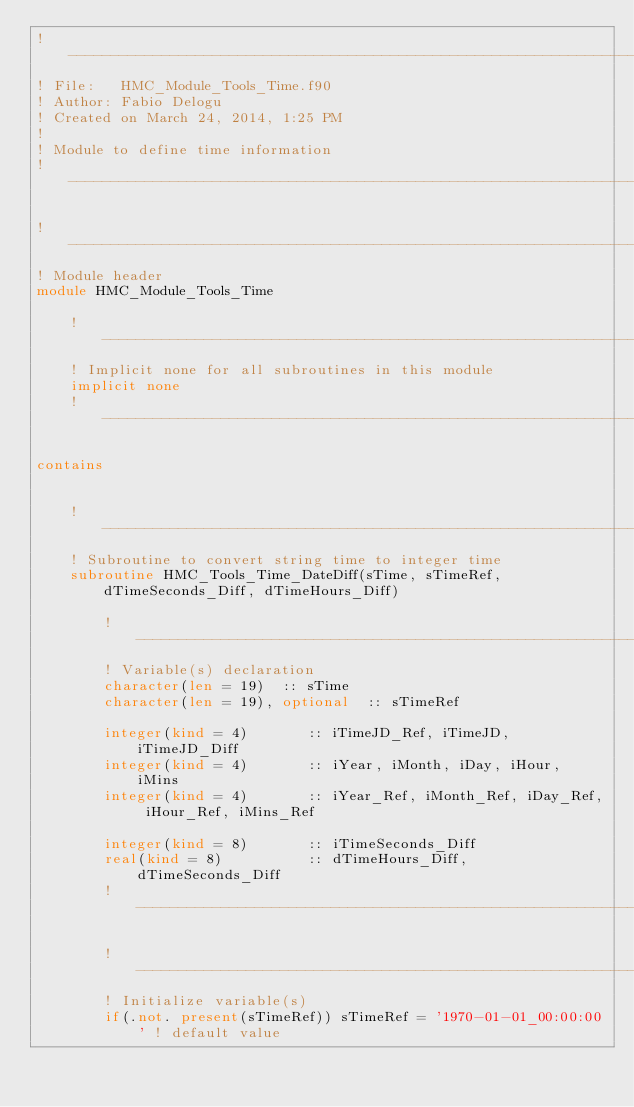Convert code to text. <code><loc_0><loc_0><loc_500><loc_500><_FORTRAN_>!------------------------------------------------------------------------------------------     
! File:   HMC_Module_Tools_Time.f90
! Author: Fabio Delogu
! Created on March 24, 2014, 1:25 PM
!
! Module to define time information
!------------------------------------------------------------------------------------------

!------------------------------------------------------------------------------------------
! Module header
module HMC_Module_Tools_Time
    
    !------------------------------------------------------------------------------------------
    ! Implicit none for all subroutines in this module
    implicit none
    !------------------------------------------------------------------------------------------
    
contains   
    
    
    !------------------------------------------------------------------------------------------
    ! Subroutine to convert string time to integer time
    subroutine HMC_Tools_Time_DateDiff(sTime, sTimeRef, dTimeSeconds_Diff, dTimeHours_Diff)
        
        !------------------------------------------------------------------------------------------
        ! Variable(s) declaration
        character(len = 19)  :: sTime
        character(len = 19), optional  :: sTimeRef
        
        integer(kind = 4)       :: iTimeJD_Ref, iTimeJD, iTimeJD_Diff
        integer(kind = 4)       :: iYear, iMonth, iDay, iHour, iMins
        integer(kind = 4)       :: iYear_Ref, iMonth_Ref, iDay_Ref, iHour_Ref, iMins_Ref
        
        integer(kind = 8)       :: iTimeSeconds_Diff
        real(kind = 8)          :: dTimeHours_Diff, dTimeSeconds_Diff
        !------------------------------------------------------------------------------------------
        
        !------------------------------------------------------------------------------------------
        ! Initialize variable(s)
        if(.not. present(sTimeRef)) sTimeRef = '1970-01-01_00:00:00' ! default value
        </code> 